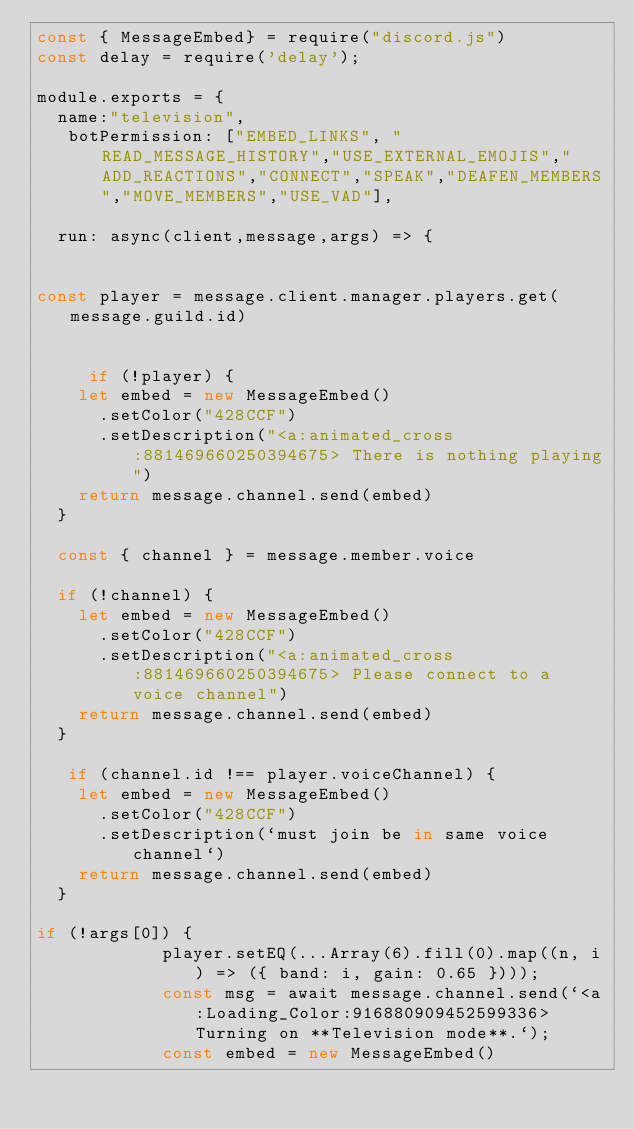<code> <loc_0><loc_0><loc_500><loc_500><_JavaScript_>const { MessageEmbed} = require("discord.js")
const delay = require('delay');

module.exports = {
  name:"television",
   botPermission: ["EMBED_LINKS", "READ_MESSAGE_HISTORY","USE_EXTERNAL_EMOJIS","ADD_REACTIONS","CONNECT","SPEAK","DEAFEN_MEMBERS","MOVE_MEMBERS","USE_VAD"],
  
  run: async(client,message,args) => {
    
   
const player = message.client.manager.players.get(message.guild.id)
  
    
     if (!player) {
    let embed = new MessageEmbed()
      .setColor("428CCF")
      .setDescription("<a:animated_cross:881469660250394675> There is nothing playing")
    return message.channel.send(embed)
  }

  const { channel } = message.member.voice

  if (!channel) {
    let embed = new MessageEmbed()
      .setColor("428CCF")
      .setDescription("<a:animated_cross:881469660250394675> Please connect to a voice channel")
    return message.channel.send(embed)
  }

   if (channel.id !== player.voiceChannel) {
    let embed = new MessageEmbed()
      .setColor("428CCF")
      .setDescription(`must join be in same voice  channel`)
    return message.channel.send(embed)
  }

if (!args[0]) {
			player.setEQ(...Array(6).fill(0).map((n, i) => ({ band: i, gain: 0.65 })));
			const msg = await message.channel.send(`<a:Loading_Color:916880909452599336>Turning on **Television mode**.`);
			const embed = new MessageEmbed()</code> 